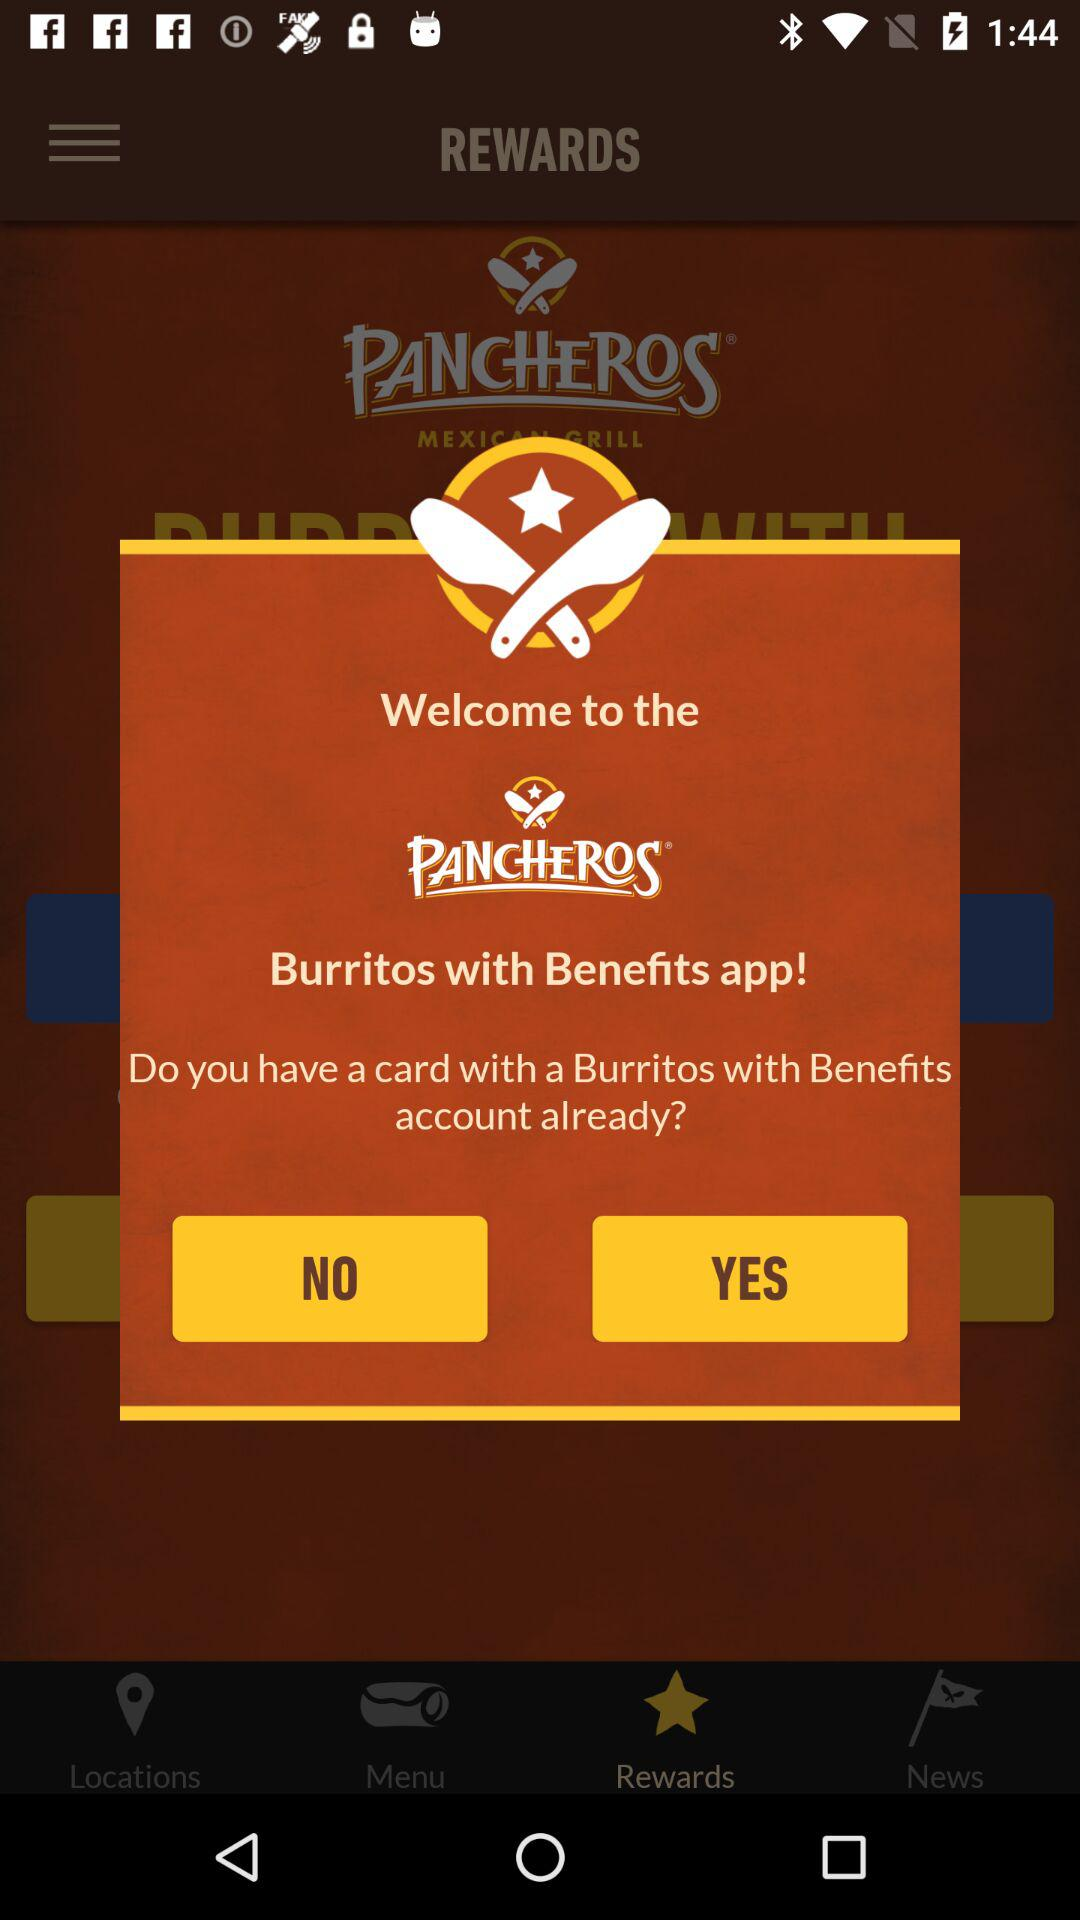Through which application we can login into Pancheros app?
When the provided information is insufficient, respond with <no answer>. <no answer> 